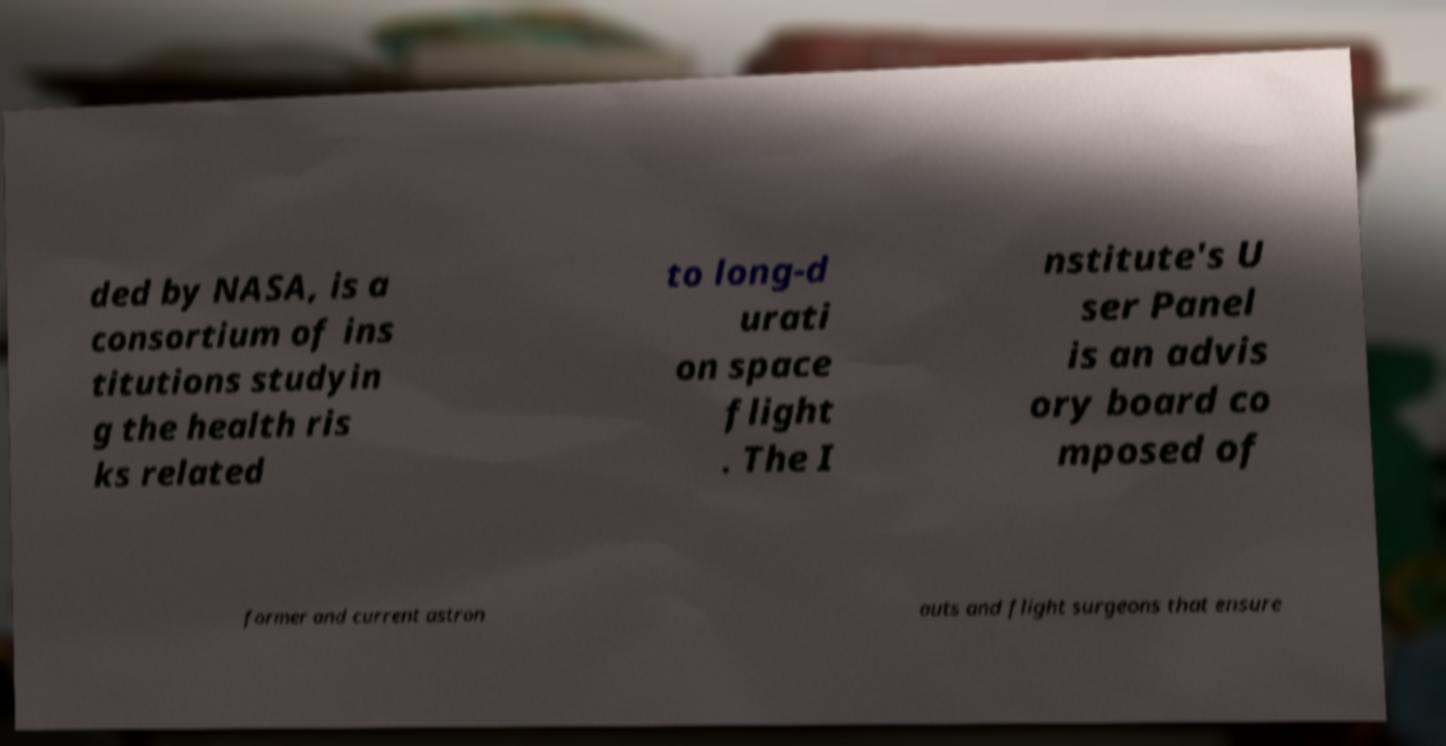There's text embedded in this image that I need extracted. Can you transcribe it verbatim? ded by NASA, is a consortium of ins titutions studyin g the health ris ks related to long-d urati on space flight . The I nstitute's U ser Panel is an advis ory board co mposed of former and current astron auts and flight surgeons that ensure 